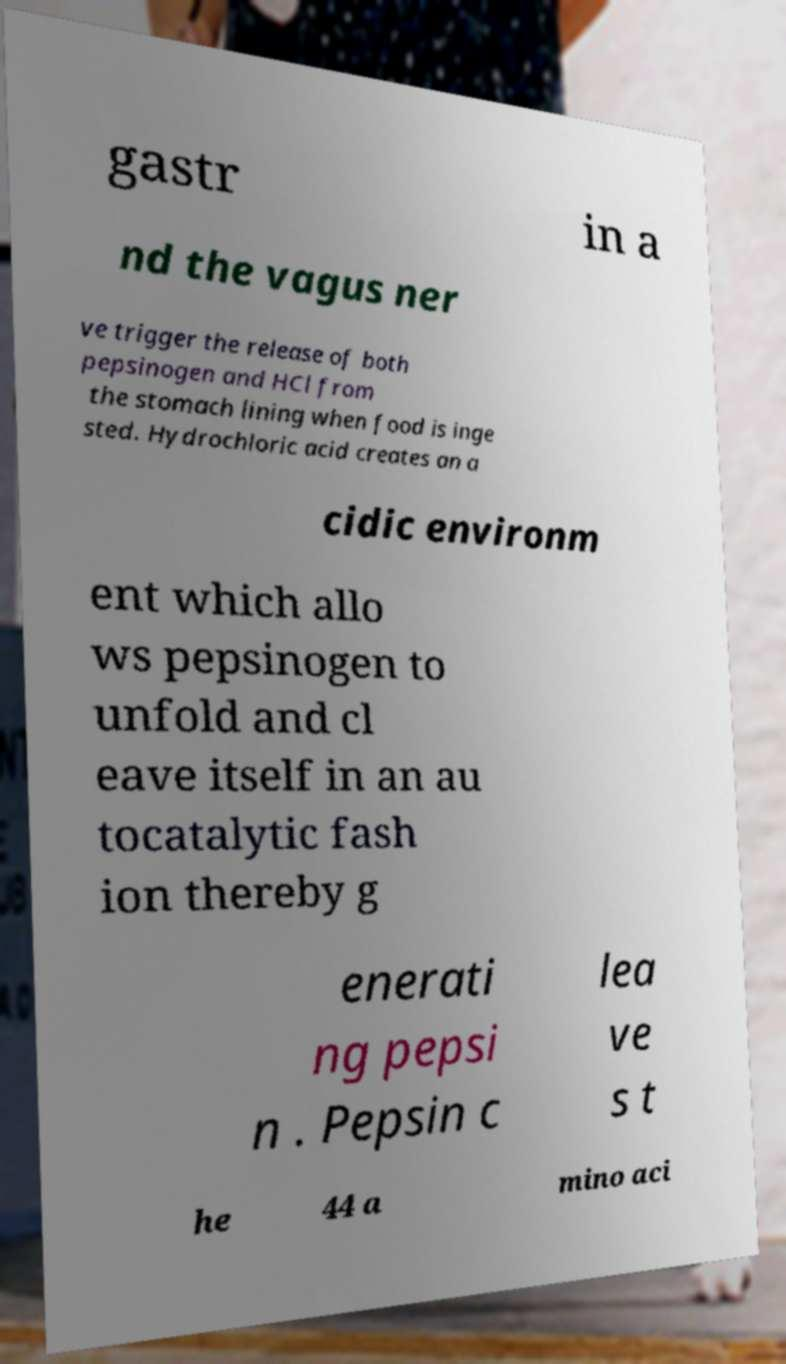Can you read and provide the text displayed in the image?This photo seems to have some interesting text. Can you extract and type it out for me? gastr in a nd the vagus ner ve trigger the release of both pepsinogen and HCl from the stomach lining when food is inge sted. Hydrochloric acid creates an a cidic environm ent which allo ws pepsinogen to unfold and cl eave itself in an au tocatalytic fash ion thereby g enerati ng pepsi n . Pepsin c lea ve s t he 44 a mino aci 